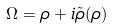<formula> <loc_0><loc_0><loc_500><loc_500>\Omega = \rho + i \tilde { \rho } ( \rho )</formula> 